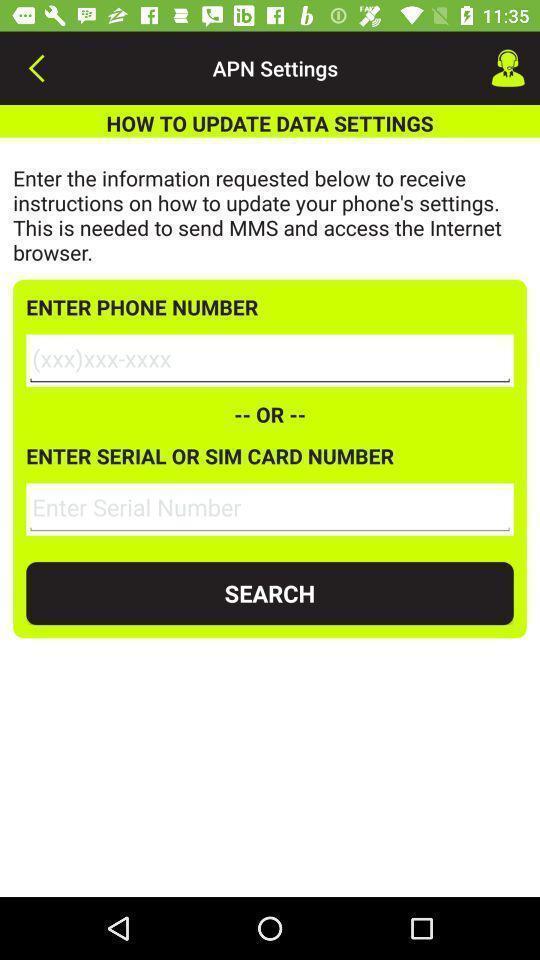What is the overall content of this screenshot? Window displayed is to update settings of data. 